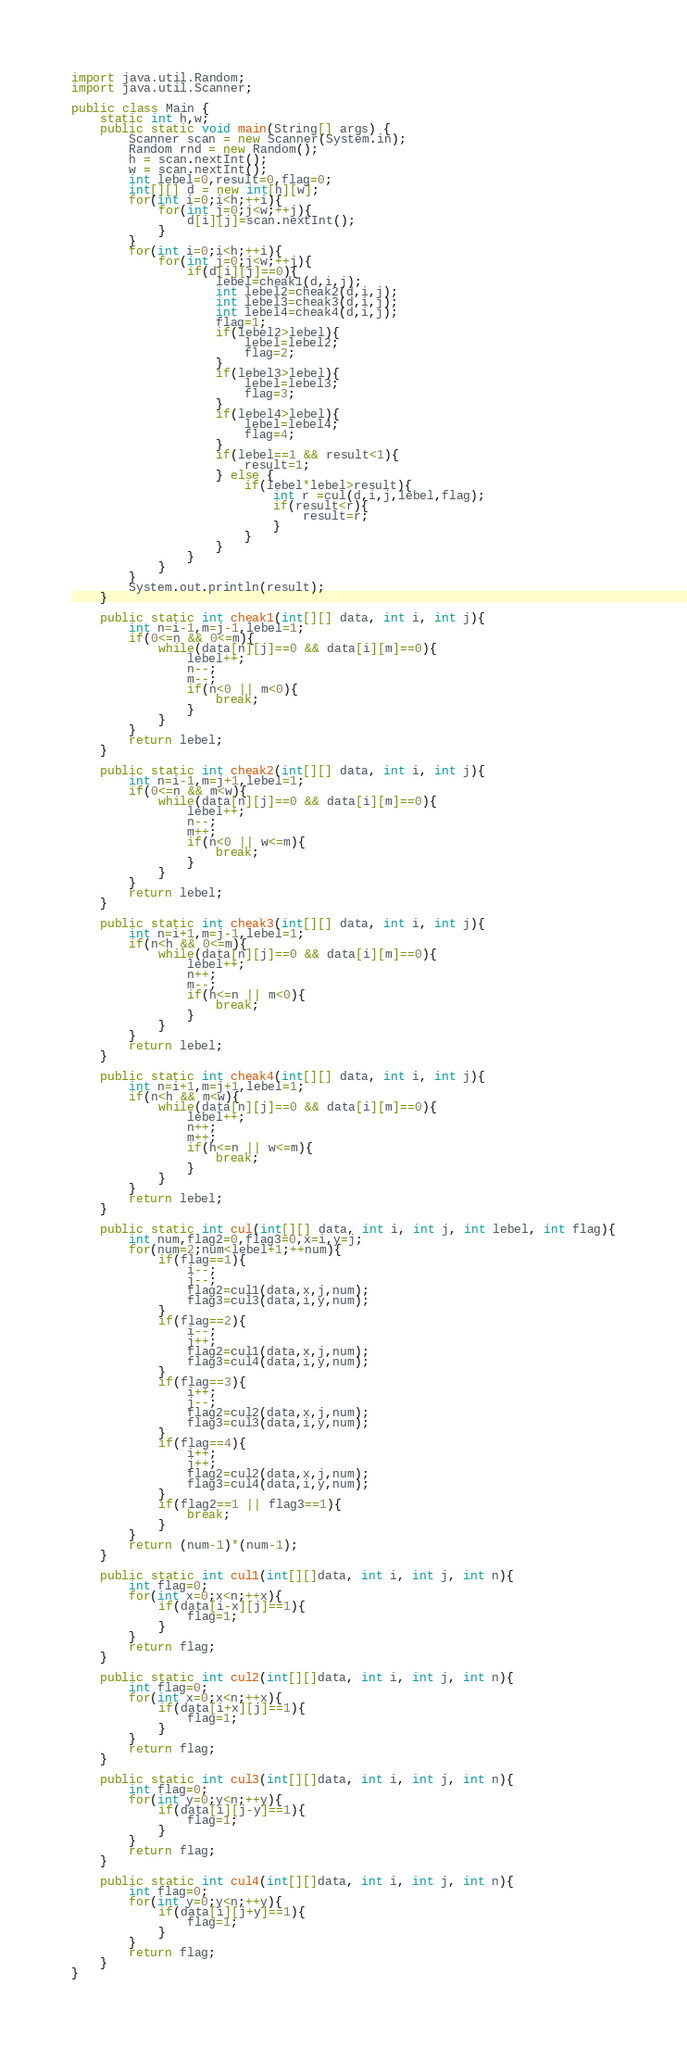<code> <loc_0><loc_0><loc_500><loc_500><_Java_>import java.util.Random;
import java.util.Scanner;

public class Main {
	static int h,w;
	public static void main(String[] args) {
		Scanner scan = new Scanner(System.in);
		Random rnd = new Random();
		h = scan.nextInt();
		w = scan.nextInt();
		int lebel=0,result=0,flag=0;
		int[][] d = new int[h][w];
		for(int i=0;i<h;++i){
			for(int j=0;j<w;++j){
				d[i][j]=scan.nextInt();
			}
		}
		for(int i=0;i<h;++i){
			for(int j=0;j<w;++j){
				if(d[i][j]==0){
					lebel=cheak1(d,i,j);
					int lebel2=cheak2(d,i,j);
					int lebel3=cheak3(d,i,j);
					int lebel4=cheak4(d,i,j);
					flag=1;
					if(lebel2>lebel){
						lebel=lebel2;
						flag=2;
					}
					if(lebel3>lebel){
						lebel=lebel3;
						flag=3;
					}
					if(lebel4>lebel){
						lebel=lebel4;
						flag=4;
					}
					if(lebel==1 && result<1){
						result=1;
					} else {
						if(lebel*lebel>result){
							int r =cul(d,i,j,lebel,flag);
							if(result<r){
								result=r;
							}
						}
					}
				}
			}
		}
		System.out.println(result);
	}

	public static int cheak1(int[][] data, int i, int j){
		int n=i-1,m=j-1,lebel=1;
		if(0<=n && 0<=m){
			while(data[n][j]==0 && data[i][m]==0){
				lebel++;
				n--;
				m--;
				if(n<0 || m<0){
					break;
				}
			}
		}
		return lebel;
	}
	
	public static int cheak2(int[][] data, int i, int j){
		int n=i-1,m=j+1,lebel=1;
		if(0<=n && m<w){
			while(data[n][j]==0 && data[i][m]==0){
				lebel++;
				n--;
				m++;
				if(n<0 || w<=m){
					break;
				}
			}
		}
		return lebel;
	}
	
	public static int cheak3(int[][] data, int i, int j){
		int n=i+1,m=j-1,lebel=1;
		if(n<h && 0<=m){
			while(data[n][j]==0 && data[i][m]==0){
				lebel++;
				n++;
				m--;
				if(h<=n || m<0){
					break;
				}
			}
		}
		return lebel;
	}
	
	public static int cheak4(int[][] data, int i, int j){
		int n=i+1,m=j+1,lebel=1;
		if(n<h && m<w){
			while(data[n][j]==0 && data[i][m]==0){
				lebel++;
				n++;
				m++;
				if(h<=n || w<=m){
					break;
				}
			}
		}
		return lebel;
	}

	public static int cul(int[][] data, int i, int j, int lebel, int flag){
		int num,flag2=0,flag3=0,x=i,y=j;
		for(num=2;num<lebel+1;++num){
			if(flag==1){
				i--;
				j--;
				flag2=cul1(data,x,j,num);
				flag3=cul3(data,i,y,num);
			}
			if(flag==2){
				i--;
				j++;
				flag2=cul1(data,x,j,num);
				flag3=cul4(data,i,y,num);
			}
			if(flag==3){
				i++;
				j--;
				flag2=cul2(data,x,j,num);
				flag3=cul3(data,i,y,num);
			}
			if(flag==4){
				i++;
				j++;
				flag2=cul2(data,x,j,num);
				flag3=cul4(data,i,y,num);
			}
			if(flag2==1 || flag3==1){
				break;
			}
		}
		return (num-1)*(num-1);
	}
	
	public static int cul1(int[][]data, int i, int j, int n){
		int flag=0;
		for(int x=0;x<n;++x){
			if(data[i-x][j]==1){
				flag=1;
			}
		}
		return flag;
	}
	
	public static int cul2(int[][]data, int i, int j, int n){
		int flag=0;
		for(int x=0;x<n;++x){
			if(data[i+x][j]==1){
				flag=1;
			}
		}
		return flag;
	}
	
	public static int cul3(int[][]data, int i, int j, int n){
		int flag=0;
		for(int y=0;y<n;++y){
			if(data[i][j-y]==1){
				flag=1;
			}
		}
		return flag;
	}

	public static int cul4(int[][]data, int i, int j, int n){
		int flag=0;
		for(int y=0;y<n;++y){
			if(data[i][j+y]==1){
				flag=1;
			}
		}
		return flag;
	}
}</code> 